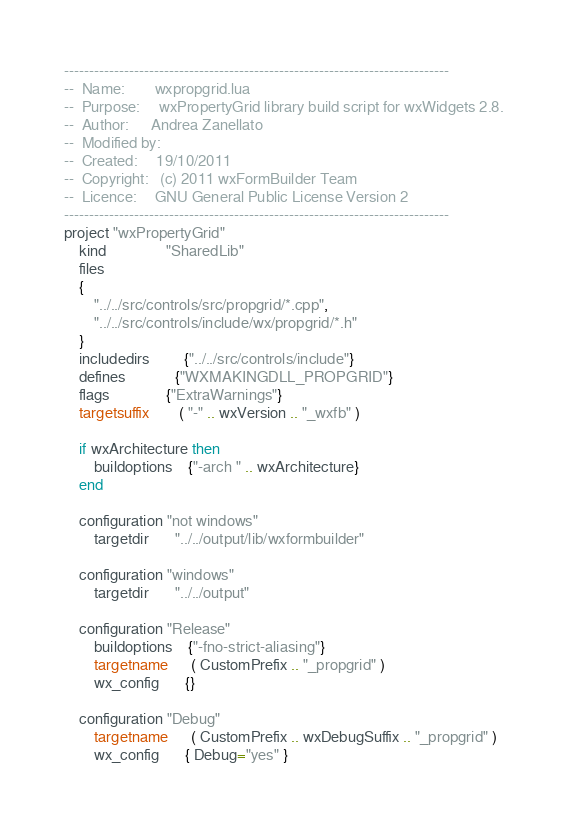<code> <loc_0><loc_0><loc_500><loc_500><_Lua_>-----------------------------------------------------------------------------
--  Name:        wxpropgrid.lua
--  Purpose:     wxPropertyGrid library build script for wxWidgets 2.8.
--  Author:      Andrea Zanellato
--  Modified by: 
--  Created:     19/10/2011
--  Copyright:   (c) 2011 wxFormBuilder Team
--  Licence:     GNU General Public License Version 2
-----------------------------------------------------------------------------
project "wxPropertyGrid"
    kind                "SharedLib"
    files
    {
        "../../src/controls/src/propgrid/*.cpp",
        "../../src/controls/include/wx/propgrid/*.h"
    }
    includedirs         {"../../src/controls/include"}
    defines             {"WXMAKINGDLL_PROPGRID"}
    flags               {"ExtraWarnings"}
    targetsuffix        ( "-" .. wxVersion .. "_wxfb" )
	
	if wxArchitecture then
		buildoptions	{"-arch " .. wxArchitecture}
	end

    configuration "not windows"
        targetdir       "../../output/lib/wxformbuilder"

    configuration "windows"
        targetdir       "../../output"

    configuration "Release"
        buildoptions    {"-fno-strict-aliasing"}
        targetname      ( CustomPrefix .. "_propgrid" )
        wx_config       {}

    configuration "Debug"
        targetname      ( CustomPrefix .. wxDebugSuffix .. "_propgrid" )
        wx_config       { Debug="yes" }
</code> 